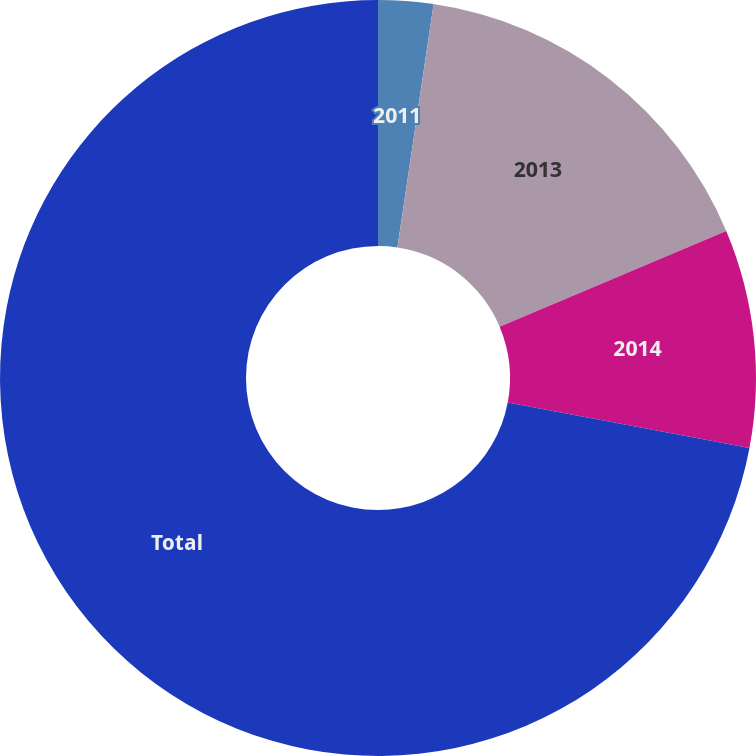<chart> <loc_0><loc_0><loc_500><loc_500><pie_chart><fcel>2011<fcel>2013<fcel>2014<fcel>Total<nl><fcel>2.35%<fcel>16.29%<fcel>9.32%<fcel>72.03%<nl></chart> 